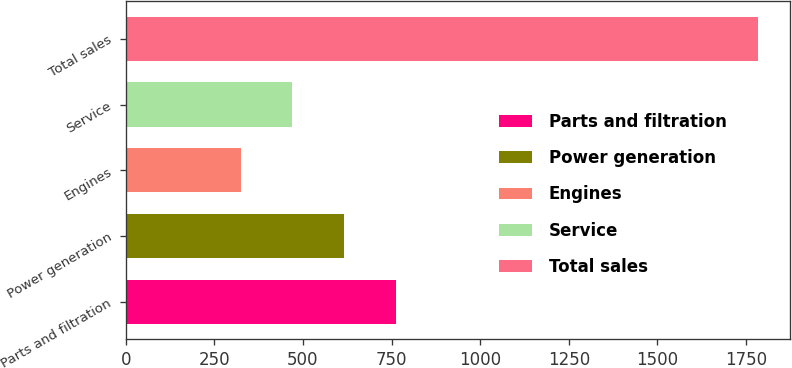Convert chart. <chart><loc_0><loc_0><loc_500><loc_500><bar_chart><fcel>Parts and filtration<fcel>Power generation<fcel>Engines<fcel>Service<fcel>Total sales<nl><fcel>762<fcel>616<fcel>324<fcel>470<fcel>1784<nl></chart> 